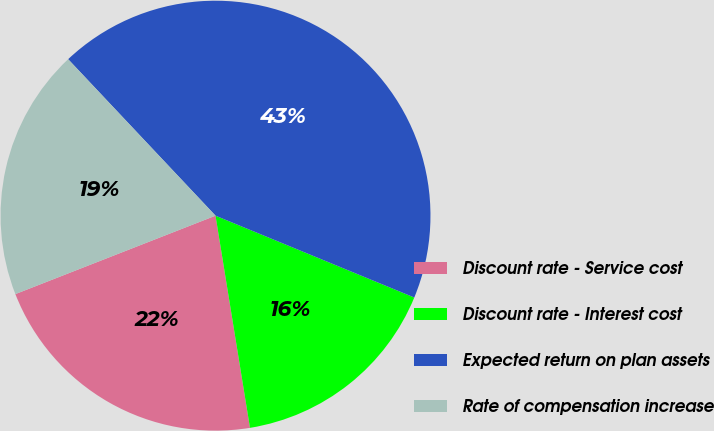Convert chart. <chart><loc_0><loc_0><loc_500><loc_500><pie_chart><fcel>Discount rate - Service cost<fcel>Discount rate - Interest cost<fcel>Expected return on plan assets<fcel>Rate of compensation increase<nl><fcel>21.62%<fcel>16.22%<fcel>43.24%<fcel>18.92%<nl></chart> 